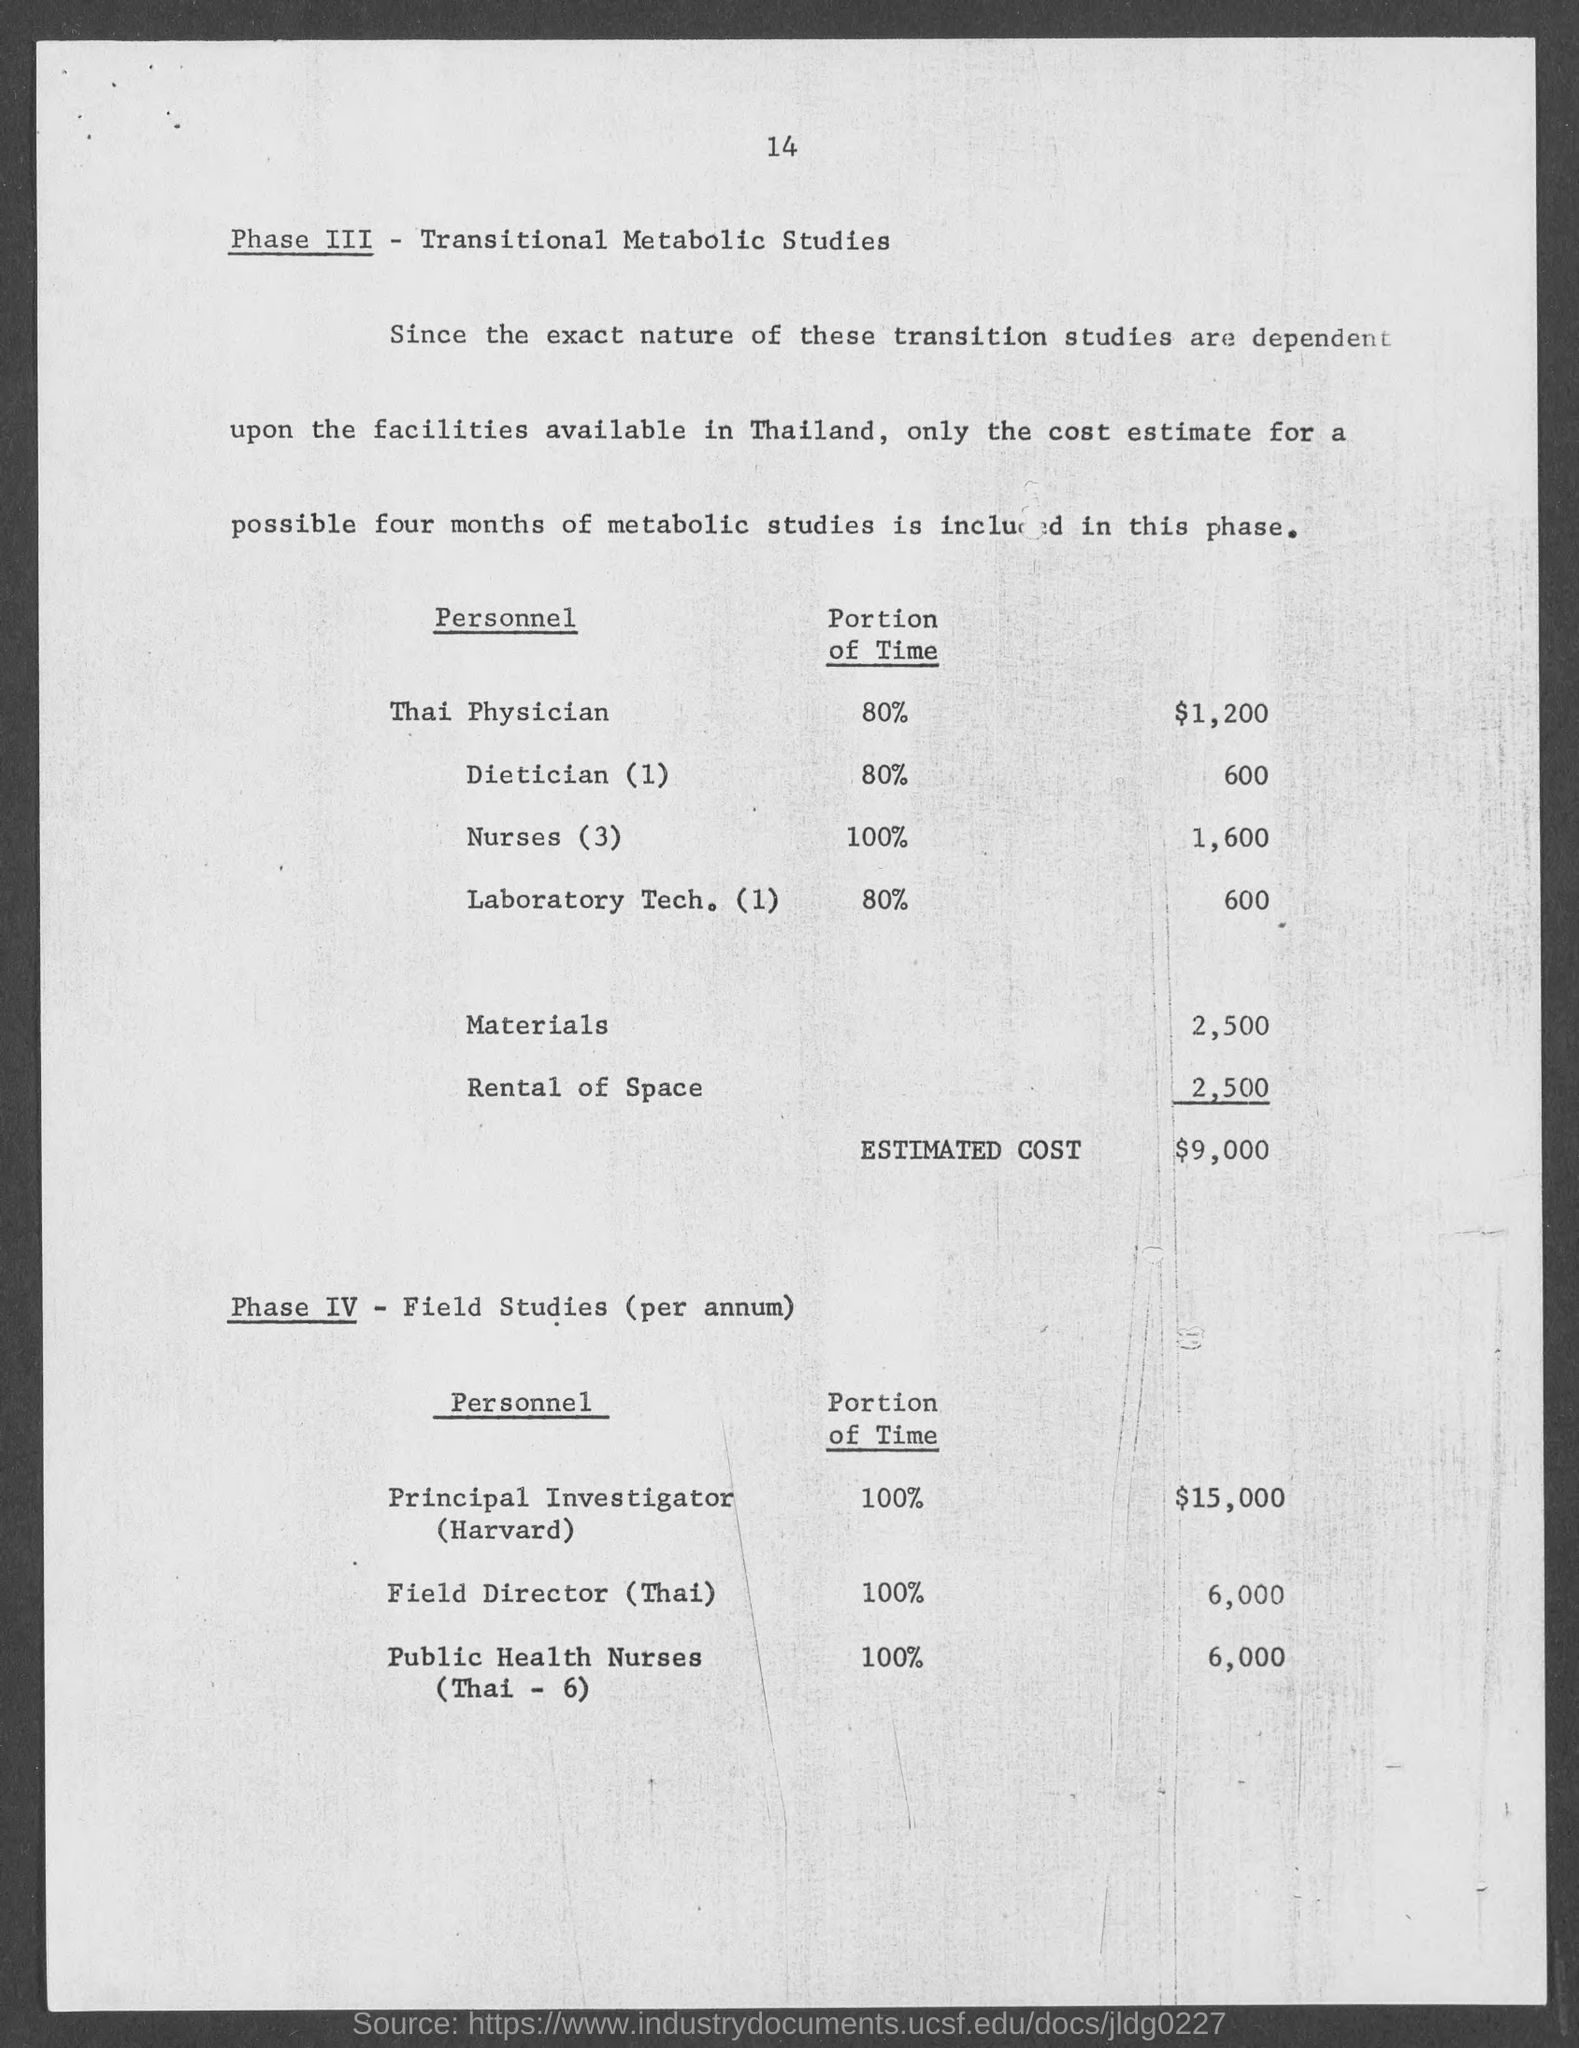What details are provided about Phase IV in the document? Phase IV details Field Studies carried out per annum, listing personnel including a Principal Investigator (Harvard) at 100% time for $15,000, a Thai Field Director at 100% for $6,000, and Public Health Nurses (Thai - 6) at 100% with a total cost of $6,000. 